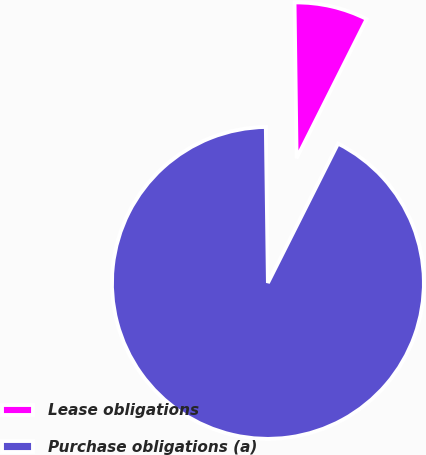Convert chart to OTSL. <chart><loc_0><loc_0><loc_500><loc_500><pie_chart><fcel>Lease obligations<fcel>Purchase obligations (a)<nl><fcel>7.63%<fcel>92.37%<nl></chart> 